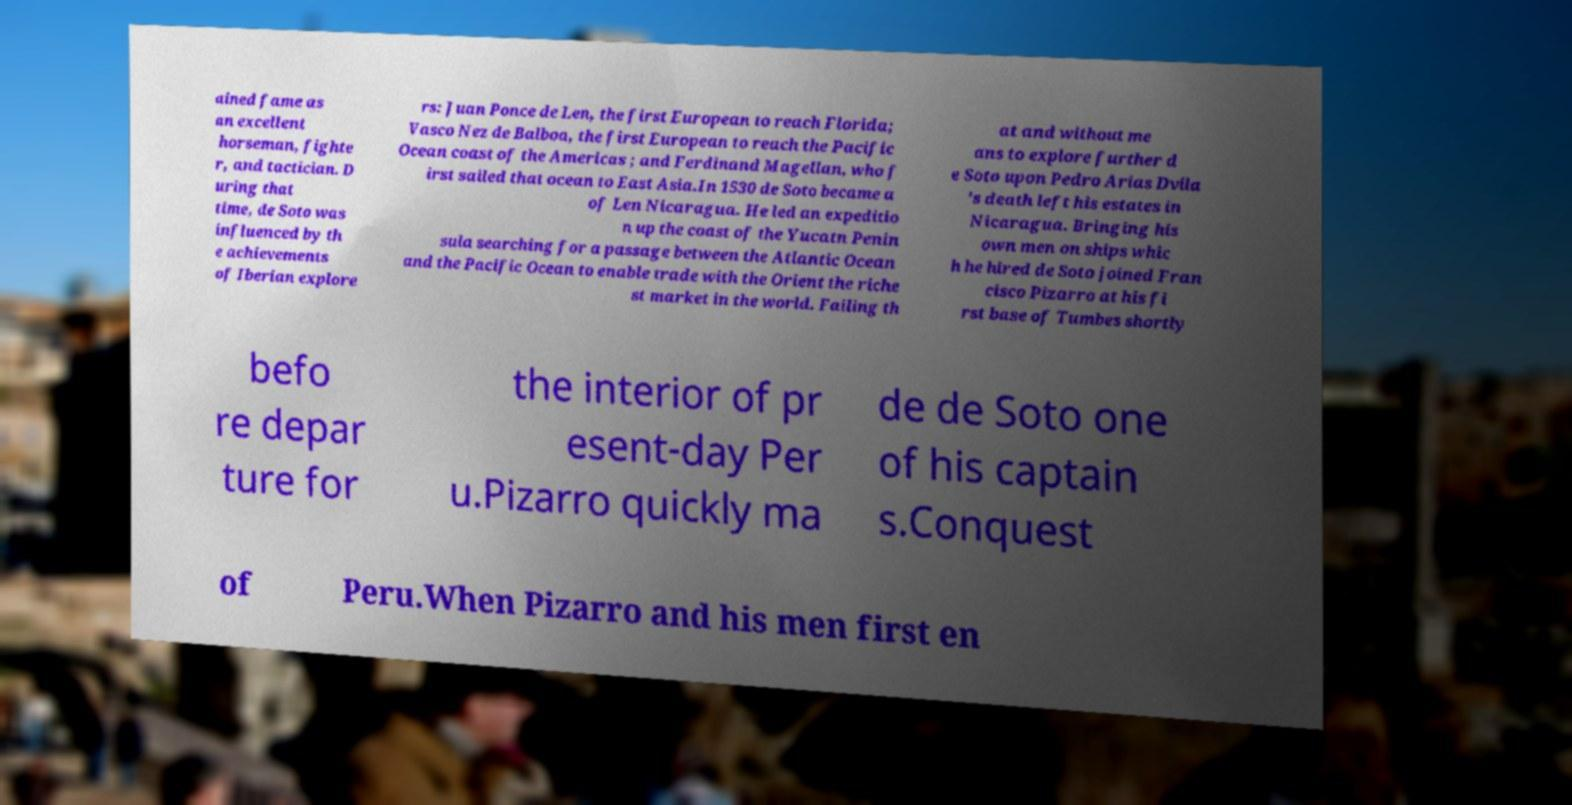Could you assist in decoding the text presented in this image and type it out clearly? ained fame as an excellent horseman, fighte r, and tactician. D uring that time, de Soto was influenced by th e achievements of Iberian explore rs: Juan Ponce de Len, the first European to reach Florida; Vasco Nez de Balboa, the first European to reach the Pacific Ocean coast of the Americas ; and Ferdinand Magellan, who f irst sailed that ocean to East Asia.In 1530 de Soto became a of Len Nicaragua. He led an expeditio n up the coast of the Yucatn Penin sula searching for a passage between the Atlantic Ocean and the Pacific Ocean to enable trade with the Orient the riche st market in the world. Failing th at and without me ans to explore further d e Soto upon Pedro Arias Dvila 's death left his estates in Nicaragua. Bringing his own men on ships whic h he hired de Soto joined Fran cisco Pizarro at his fi rst base of Tumbes shortly befo re depar ture for the interior of pr esent-day Per u.Pizarro quickly ma de de Soto one of his captain s.Conquest of Peru.When Pizarro and his men first en 